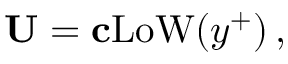Convert formula to latex. <formula><loc_0><loc_0><loc_500><loc_500>{ U } = { c } L o W ( y ^ { + } ) \, ,</formula> 